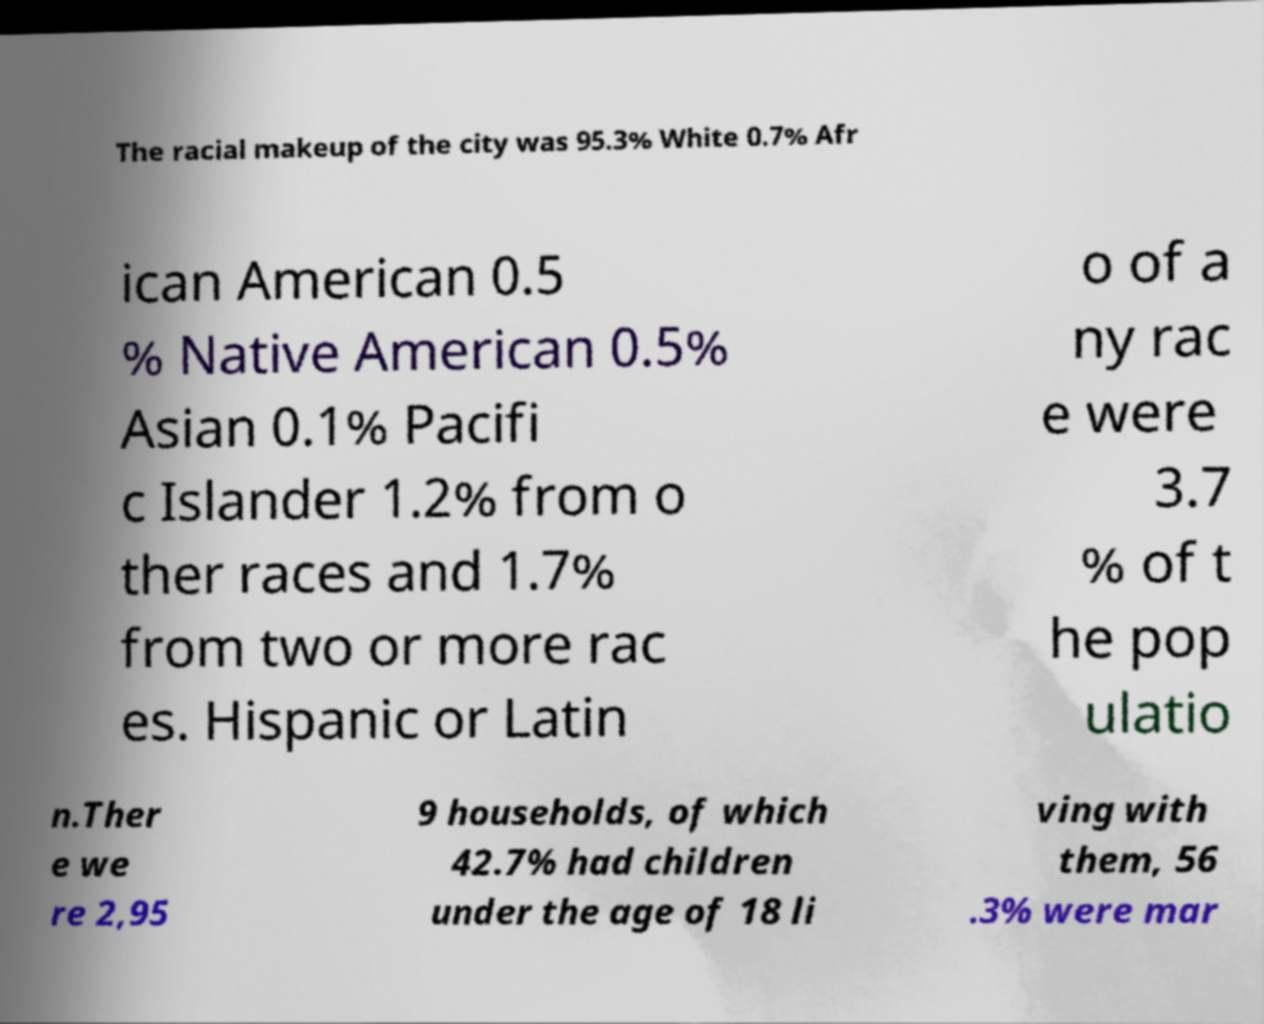Can you read and provide the text displayed in the image?This photo seems to have some interesting text. Can you extract and type it out for me? The racial makeup of the city was 95.3% White 0.7% Afr ican American 0.5 % Native American 0.5% Asian 0.1% Pacifi c Islander 1.2% from o ther races and 1.7% from two or more rac es. Hispanic or Latin o of a ny rac e were 3.7 % of t he pop ulatio n.Ther e we re 2,95 9 households, of which 42.7% had children under the age of 18 li ving with them, 56 .3% were mar 